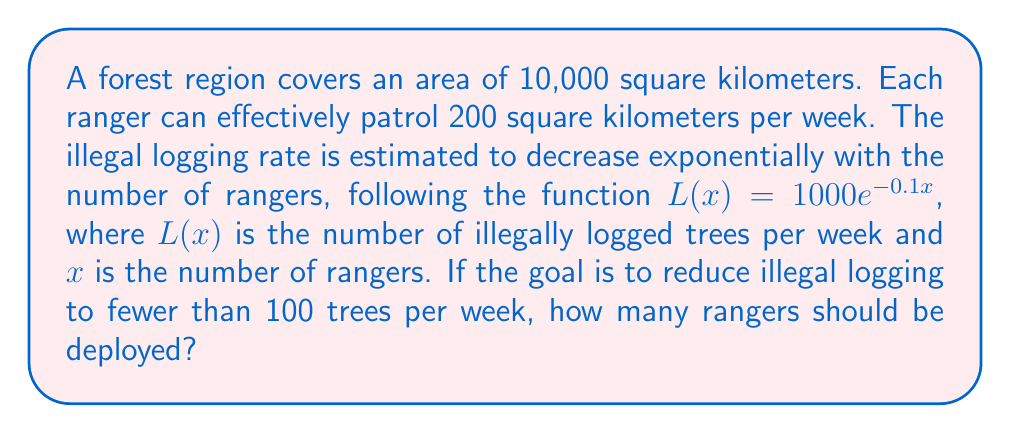Can you solve this math problem? Let's approach this step-by-step:

1) We need to solve the inequality:
   $L(x) < 100$

2) Substituting the given function:
   $1000e^{-0.1x} < 100$

3) Divide both sides by 1000:
   $e^{-0.1x} < 0.1$

4) Take the natural logarithm of both sides:
   $\ln(e^{-0.1x}) < \ln(0.1)$

5) Simplify the left side:
   $-0.1x < \ln(0.1)$

6) Divide both sides by -0.1 (note that the inequality sign flips):
   $x > -\frac{\ln(0.1)}{0.1}$

7) Calculate the right side:
   $x > 23.026$

8) Since we need a whole number of rangers, we round up:
   $x \geq 24$

9) Check if this number of rangers can cover the entire area:
   Area covered = $24 \times 200 = 4800$ sq km
   This is less than the total area of 10,000 sq km.

10) Calculate the minimum number of rangers needed to cover the entire area:
    $\frac{10000}{200} = 50$ rangers

Therefore, we need the maximum of these two numbers: 50 rangers.
Answer: 50 rangers 